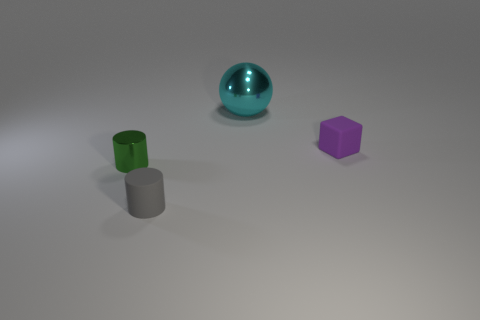How many objects are big cyan metal spheres or large purple rubber cylinders?
Make the answer very short. 1. What is the tiny cylinder that is behind the rubber object to the left of the cyan shiny object made of?
Provide a short and direct response. Metal. What color is the block that is the same size as the gray matte object?
Make the answer very short. Purple. What material is the object that is behind the small rubber thing that is behind the matte object that is to the left of the big object made of?
Make the answer very short. Metal. What number of things are either tiny things that are behind the green shiny cylinder or things that are left of the tiny purple rubber object?
Make the answer very short. 4. There is a small object right of the shiny object that is behind the small purple thing; what shape is it?
Give a very brief answer. Cube. Is there a green object that has the same material as the small block?
Your answer should be compact. No. There is another thing that is the same shape as the gray rubber object; what is its color?
Keep it short and to the point. Green. Is the number of small green metallic objects behind the big cyan object less than the number of cyan metallic balls that are right of the gray cylinder?
Provide a short and direct response. Yes. What number of other objects are there of the same shape as the big metal object?
Provide a succinct answer. 0. 